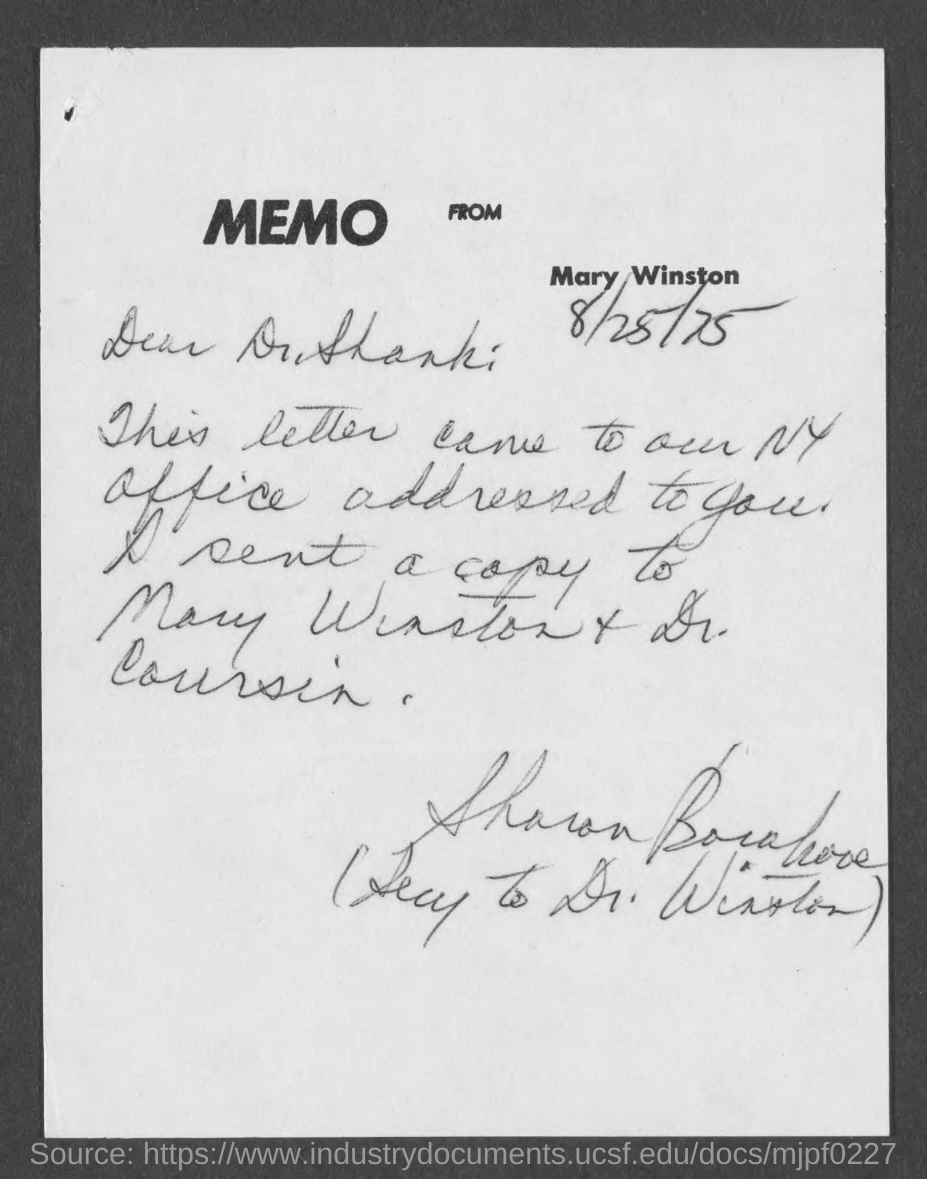From whom is the memo?
Provide a succinct answer. Mary Winston. When is the document dated?
Offer a terse response. 8/25/75. What type of documentation is this?
Your answer should be compact. Memo. 